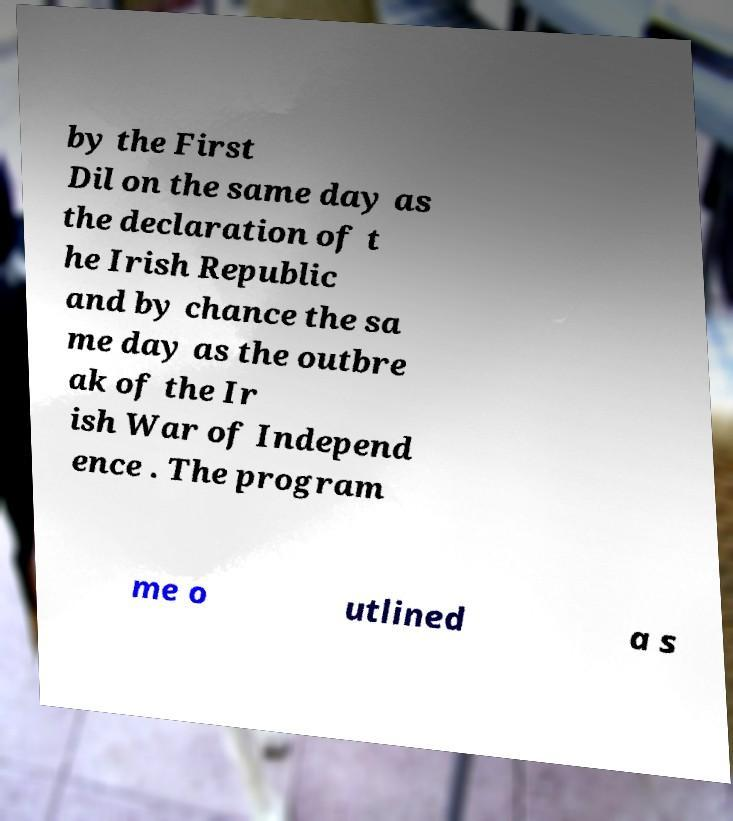Can you accurately transcribe the text from the provided image for me? by the First Dil on the same day as the declaration of t he Irish Republic and by chance the sa me day as the outbre ak of the Ir ish War of Independ ence . The program me o utlined a s 